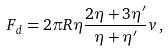Convert formula to latex. <formula><loc_0><loc_0><loc_500><loc_500>F _ { d } = 2 \pi R \eta \frac { 2 \eta + 3 \eta ^ { \prime } } { \eta + \eta ^ { \prime } } v \, ,</formula> 